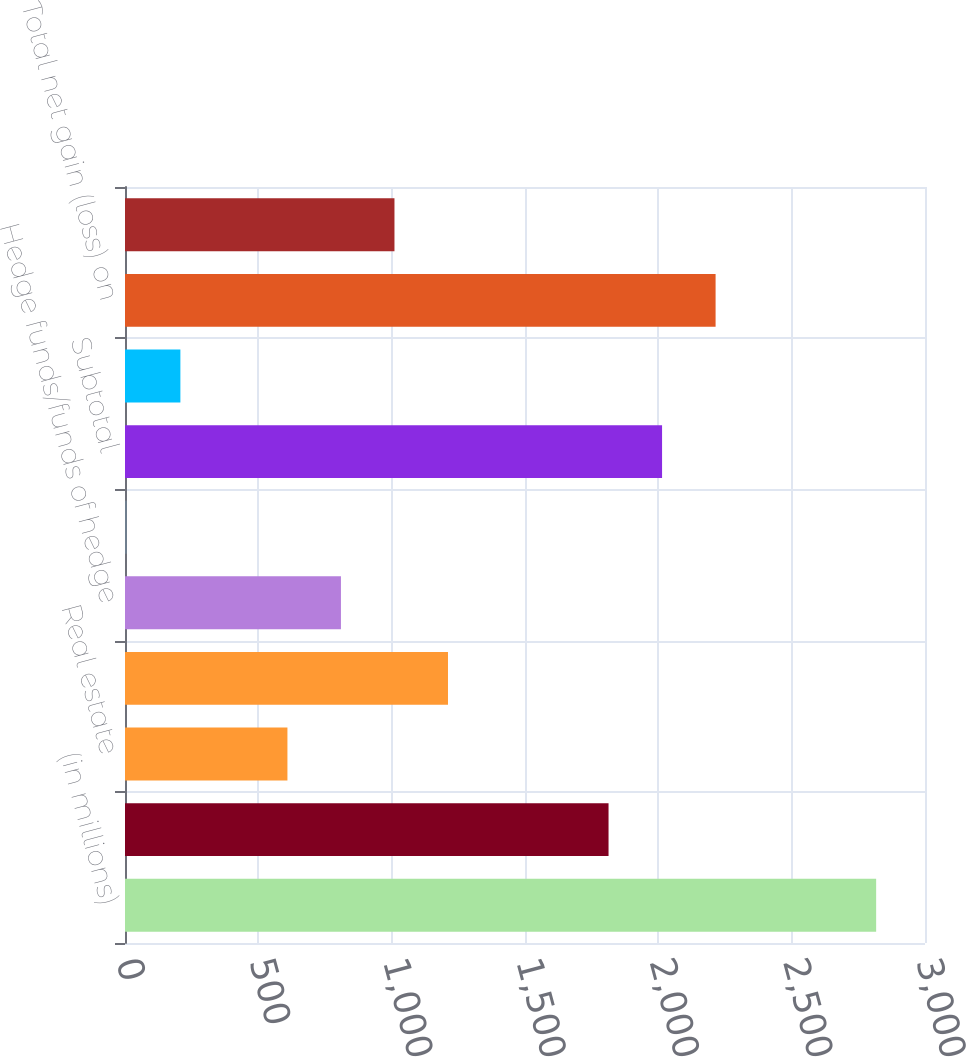Convert chart. <chart><loc_0><loc_0><loc_500><loc_500><bar_chart><fcel>(in millions)<fcel>Private equity<fcel>Real estate<fcel>Distressed credit/mortgage<fcel>Hedge funds/funds of hedge<fcel>Other investments (2)<fcel>Subtotal<fcel>Investments related to<fcel>Total net gain (loss) on<fcel>Interest and dividend income<nl><fcel>2816.8<fcel>1813.3<fcel>609.1<fcel>1211.2<fcel>809.8<fcel>7<fcel>2014<fcel>207.7<fcel>2214.7<fcel>1010.5<nl></chart> 